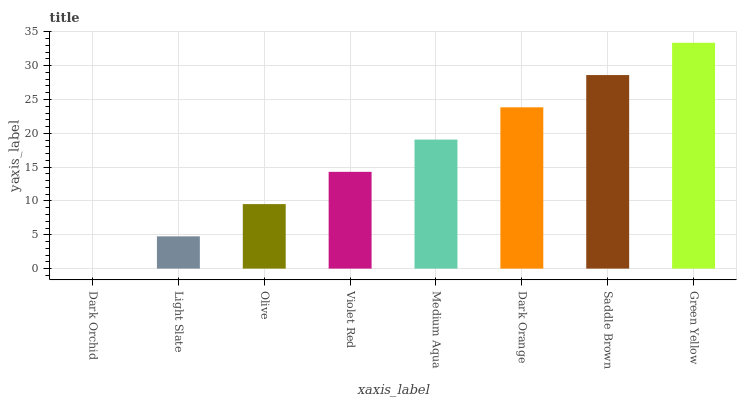Is Dark Orchid the minimum?
Answer yes or no. Yes. Is Green Yellow the maximum?
Answer yes or no. Yes. Is Light Slate the minimum?
Answer yes or no. No. Is Light Slate the maximum?
Answer yes or no. No. Is Light Slate greater than Dark Orchid?
Answer yes or no. Yes. Is Dark Orchid less than Light Slate?
Answer yes or no. Yes. Is Dark Orchid greater than Light Slate?
Answer yes or no. No. Is Light Slate less than Dark Orchid?
Answer yes or no. No. Is Medium Aqua the high median?
Answer yes or no. Yes. Is Violet Red the low median?
Answer yes or no. Yes. Is Dark Orange the high median?
Answer yes or no. No. Is Light Slate the low median?
Answer yes or no. No. 